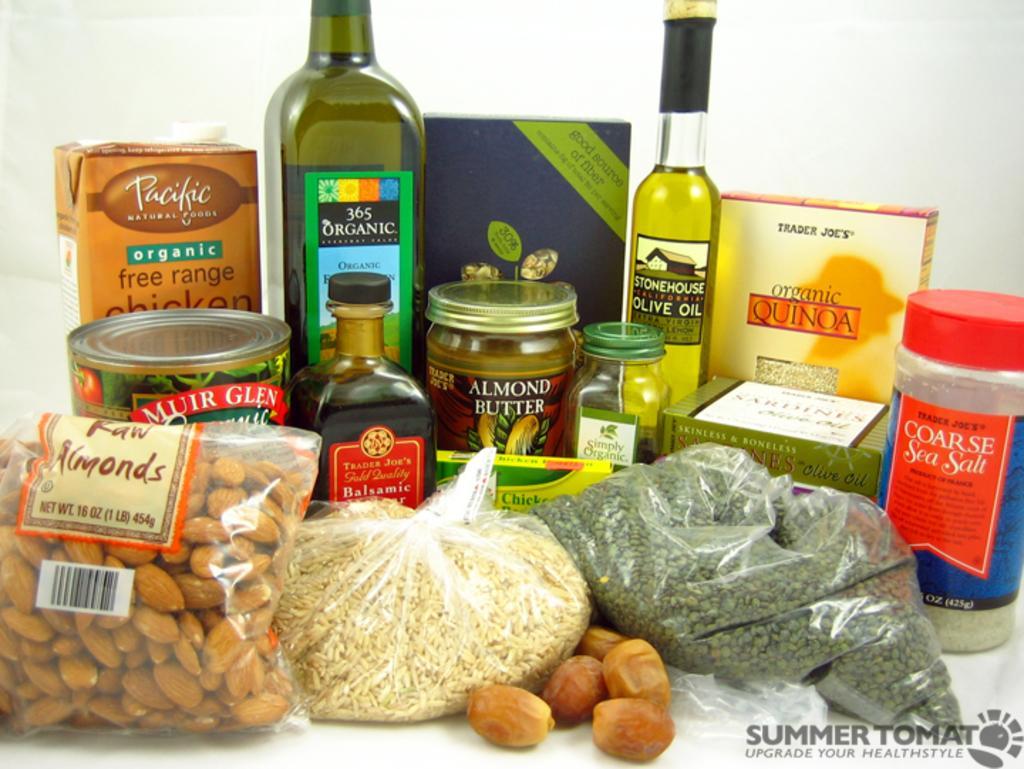Can you describe this image briefly? As we can see in the image there is a almond packet, rice, coarse sea salt, olive oil bottle, almond butter bottle, organic bottle and few other bottles. 